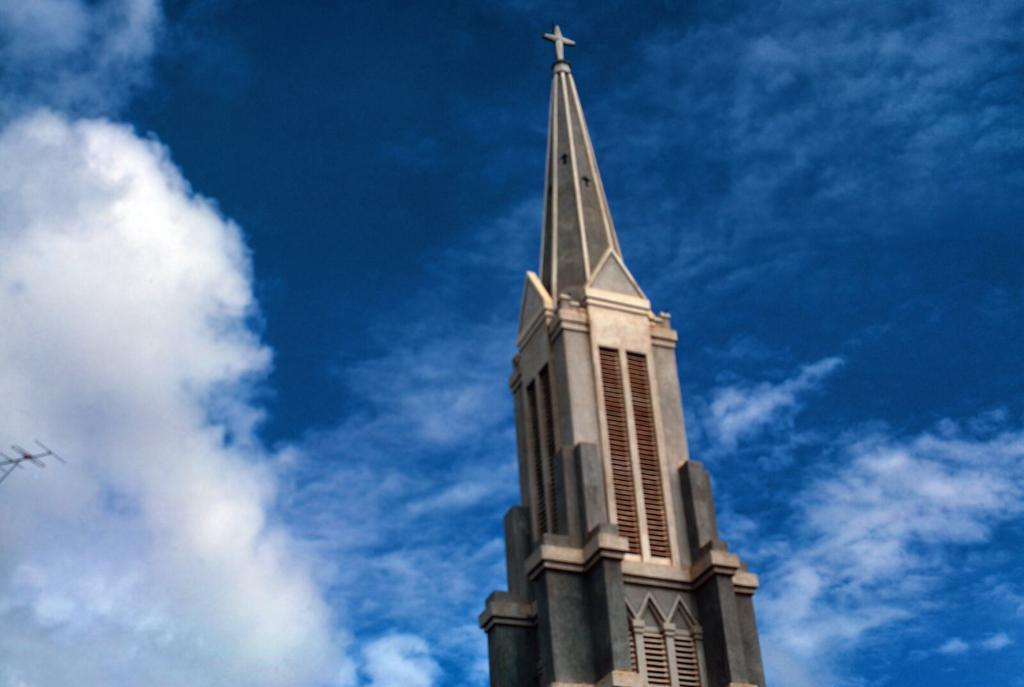What is the main structure in the image? There is a tower in the image. What is on top of the tower? The tower has a cross on it. What other feature can be seen on the tower? There is an antenna on the tower. What can be seen in the background of the image? The sky is visible in the background of the image. What is the weather like in the image? Clouds are present in the sky, indicating that it might be partly cloudy. What type of moon can be seen in the image? There is no moon visible in the image; it only features a tower with a cross and an antenna, as well as a sky with clouds. 